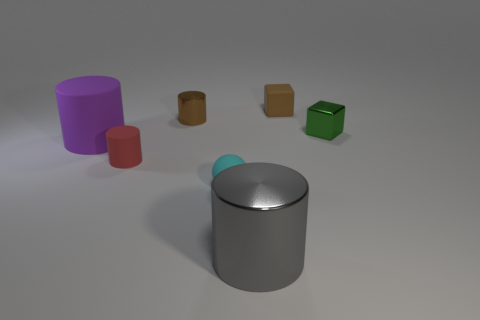Can you describe the lighting and shadows seen in the image? The lighting in the image appears to come from above, slightly to the right, casting soft-edged shadows to the left of the objects. These shadows vary in shape and length, corresponding to the form and size of each object, and they contribute to the three-dimensional feeling of the scene. 